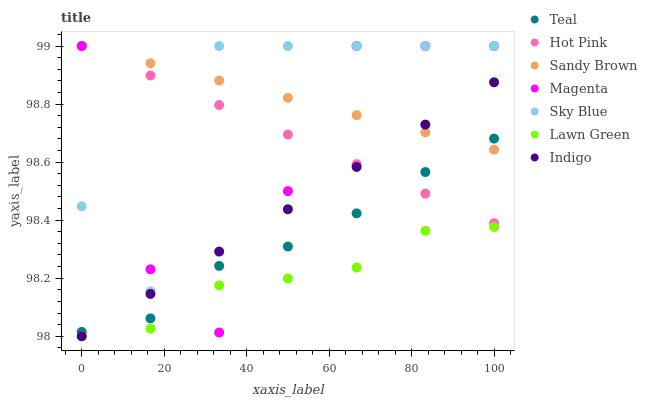Does Lawn Green have the minimum area under the curve?
Answer yes or no. Yes. Does Sandy Brown have the maximum area under the curve?
Answer yes or no. Yes. Does Indigo have the minimum area under the curve?
Answer yes or no. No. Does Indigo have the maximum area under the curve?
Answer yes or no. No. Is Hot Pink the smoothest?
Answer yes or no. Yes. Is Sky Blue the roughest?
Answer yes or no. Yes. Is Indigo the smoothest?
Answer yes or no. No. Is Indigo the roughest?
Answer yes or no. No. Does Lawn Green have the lowest value?
Answer yes or no. Yes. Does Hot Pink have the lowest value?
Answer yes or no. No. Does Sandy Brown have the highest value?
Answer yes or no. Yes. Does Indigo have the highest value?
Answer yes or no. No. Is Indigo less than Sky Blue?
Answer yes or no. Yes. Is Teal greater than Lawn Green?
Answer yes or no. Yes. Does Indigo intersect Teal?
Answer yes or no. Yes. Is Indigo less than Teal?
Answer yes or no. No. Is Indigo greater than Teal?
Answer yes or no. No. Does Indigo intersect Sky Blue?
Answer yes or no. No. 